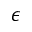<formula> <loc_0><loc_0><loc_500><loc_500>\epsilon</formula> 